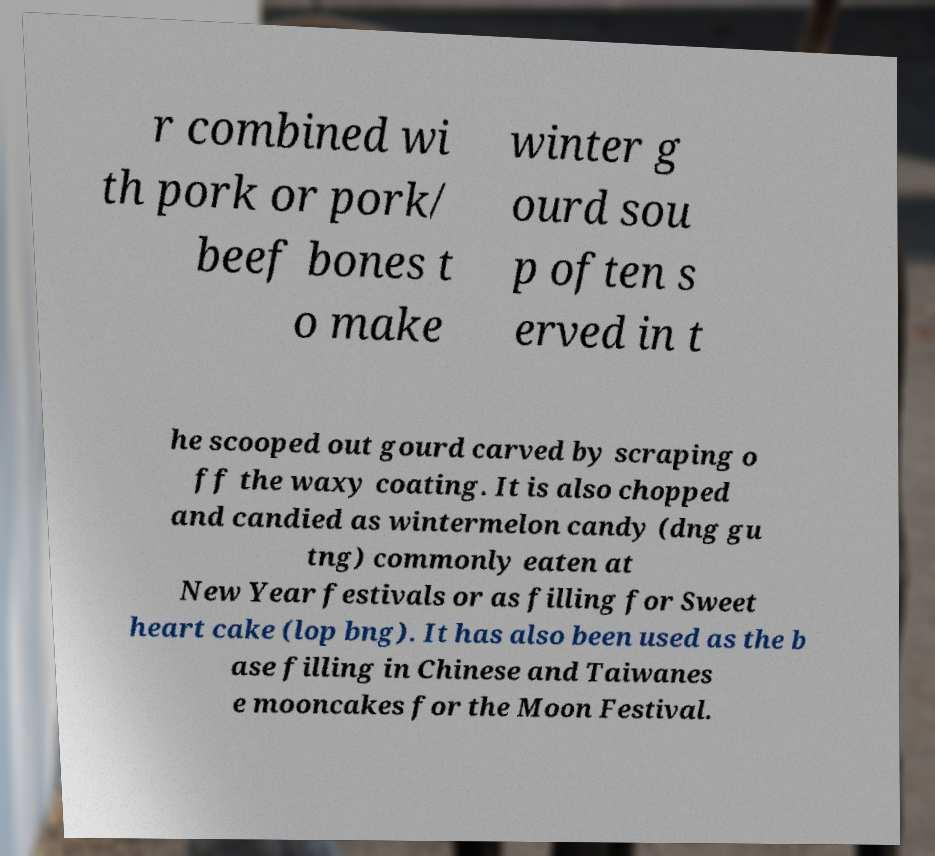Please identify and transcribe the text found in this image. r combined wi th pork or pork/ beef bones t o make winter g ourd sou p often s erved in t he scooped out gourd carved by scraping o ff the waxy coating. It is also chopped and candied as wintermelon candy (dng gu tng) commonly eaten at New Year festivals or as filling for Sweet heart cake (lop bng). It has also been used as the b ase filling in Chinese and Taiwanes e mooncakes for the Moon Festival. 